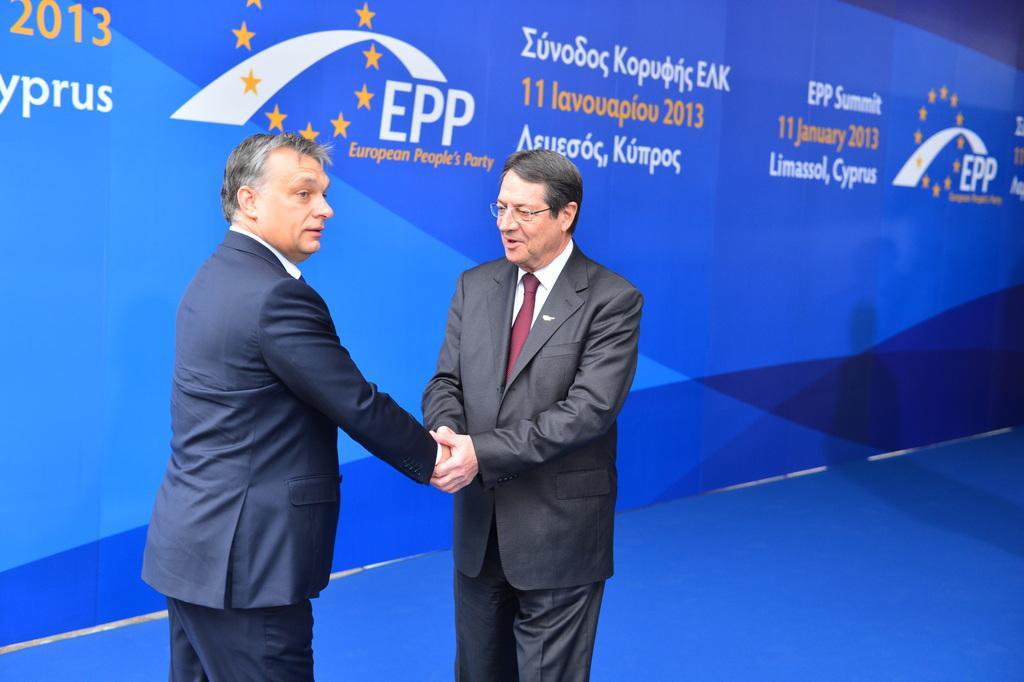In one or two sentences, can you explain what this image depicts? In this image we can see two persons are handshaking. One person is wearing specs. In the back there is a banner with text. 